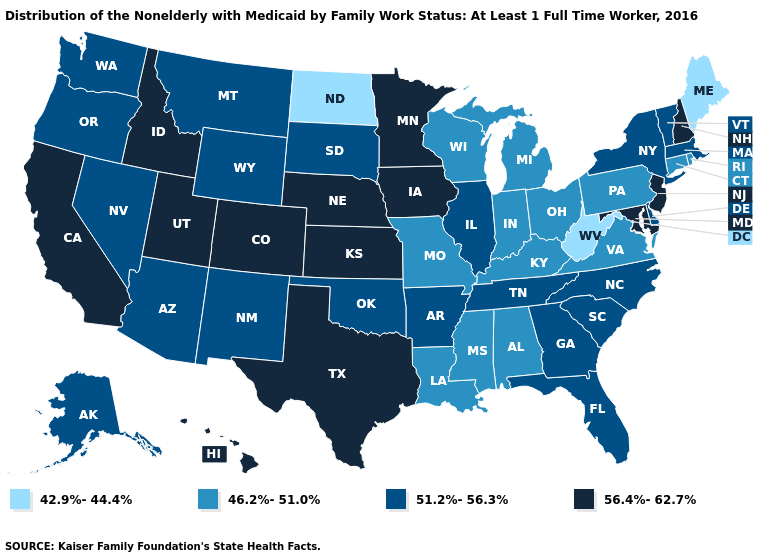What is the value of Minnesota?
Quick response, please. 56.4%-62.7%. Does Illinois have the same value as Hawaii?
Answer briefly. No. Which states have the highest value in the USA?
Be succinct. California, Colorado, Hawaii, Idaho, Iowa, Kansas, Maryland, Minnesota, Nebraska, New Hampshire, New Jersey, Texas, Utah. Name the states that have a value in the range 46.2%-51.0%?
Be succinct. Alabama, Connecticut, Indiana, Kentucky, Louisiana, Michigan, Mississippi, Missouri, Ohio, Pennsylvania, Rhode Island, Virginia, Wisconsin. Does the map have missing data?
Answer briefly. No. Does Texas have the highest value in the USA?
Be succinct. Yes. Name the states that have a value in the range 42.9%-44.4%?
Quick response, please. Maine, North Dakota, West Virginia. Name the states that have a value in the range 42.9%-44.4%?
Answer briefly. Maine, North Dakota, West Virginia. Which states have the highest value in the USA?
Answer briefly. California, Colorado, Hawaii, Idaho, Iowa, Kansas, Maryland, Minnesota, Nebraska, New Hampshire, New Jersey, Texas, Utah. Is the legend a continuous bar?
Write a very short answer. No. Among the states that border Rhode Island , which have the lowest value?
Give a very brief answer. Connecticut. Does Hawaii have the highest value in the West?
Short answer required. Yes. Name the states that have a value in the range 56.4%-62.7%?
Write a very short answer. California, Colorado, Hawaii, Idaho, Iowa, Kansas, Maryland, Minnesota, Nebraska, New Hampshire, New Jersey, Texas, Utah. Does New Hampshire have a higher value than Washington?
Short answer required. Yes. Which states have the lowest value in the USA?
Give a very brief answer. Maine, North Dakota, West Virginia. 